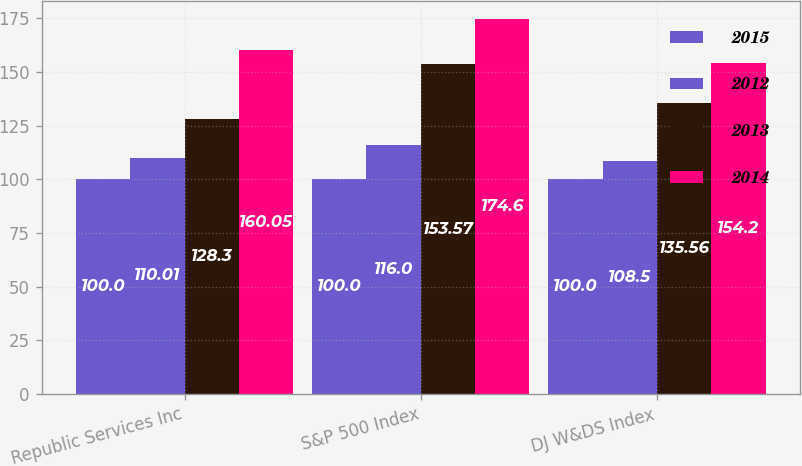Convert chart. <chart><loc_0><loc_0><loc_500><loc_500><stacked_bar_chart><ecel><fcel>Republic Services Inc<fcel>S&P 500 Index<fcel>DJ W&DS Index<nl><fcel>2015<fcel>100<fcel>100<fcel>100<nl><fcel>2012<fcel>110.01<fcel>116<fcel>108.5<nl><fcel>2013<fcel>128.3<fcel>153.57<fcel>135.56<nl><fcel>2014<fcel>160.05<fcel>174.6<fcel>154.2<nl></chart> 